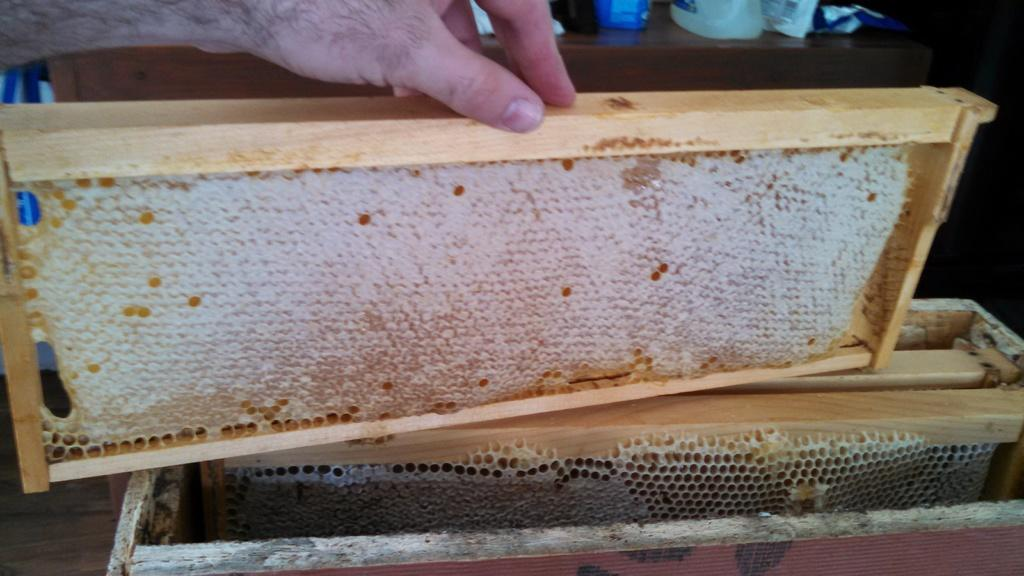What is the main subject in the foreground of the image? There is a honeycomb in the foreground of the image. How is the honeycomb attached to the wooden structure? The honeycomb is attached to a wooden structure. What is the person's hand doing in the image? A person's hand is holding the wooden structure. What can be seen on the wooden surface in the background of the image? There are objects on a wooden surface in the background of the image. What type of dinner is being served on the can in the image? There is no dinner or can present in the image; it features a honeycomb attached to a wooden structure. What is the weight of the honeycomb in the image? The weight of the honeycomb cannot be determined from the image alone, as it depends on factors such as the size and density of the honeycomb. 